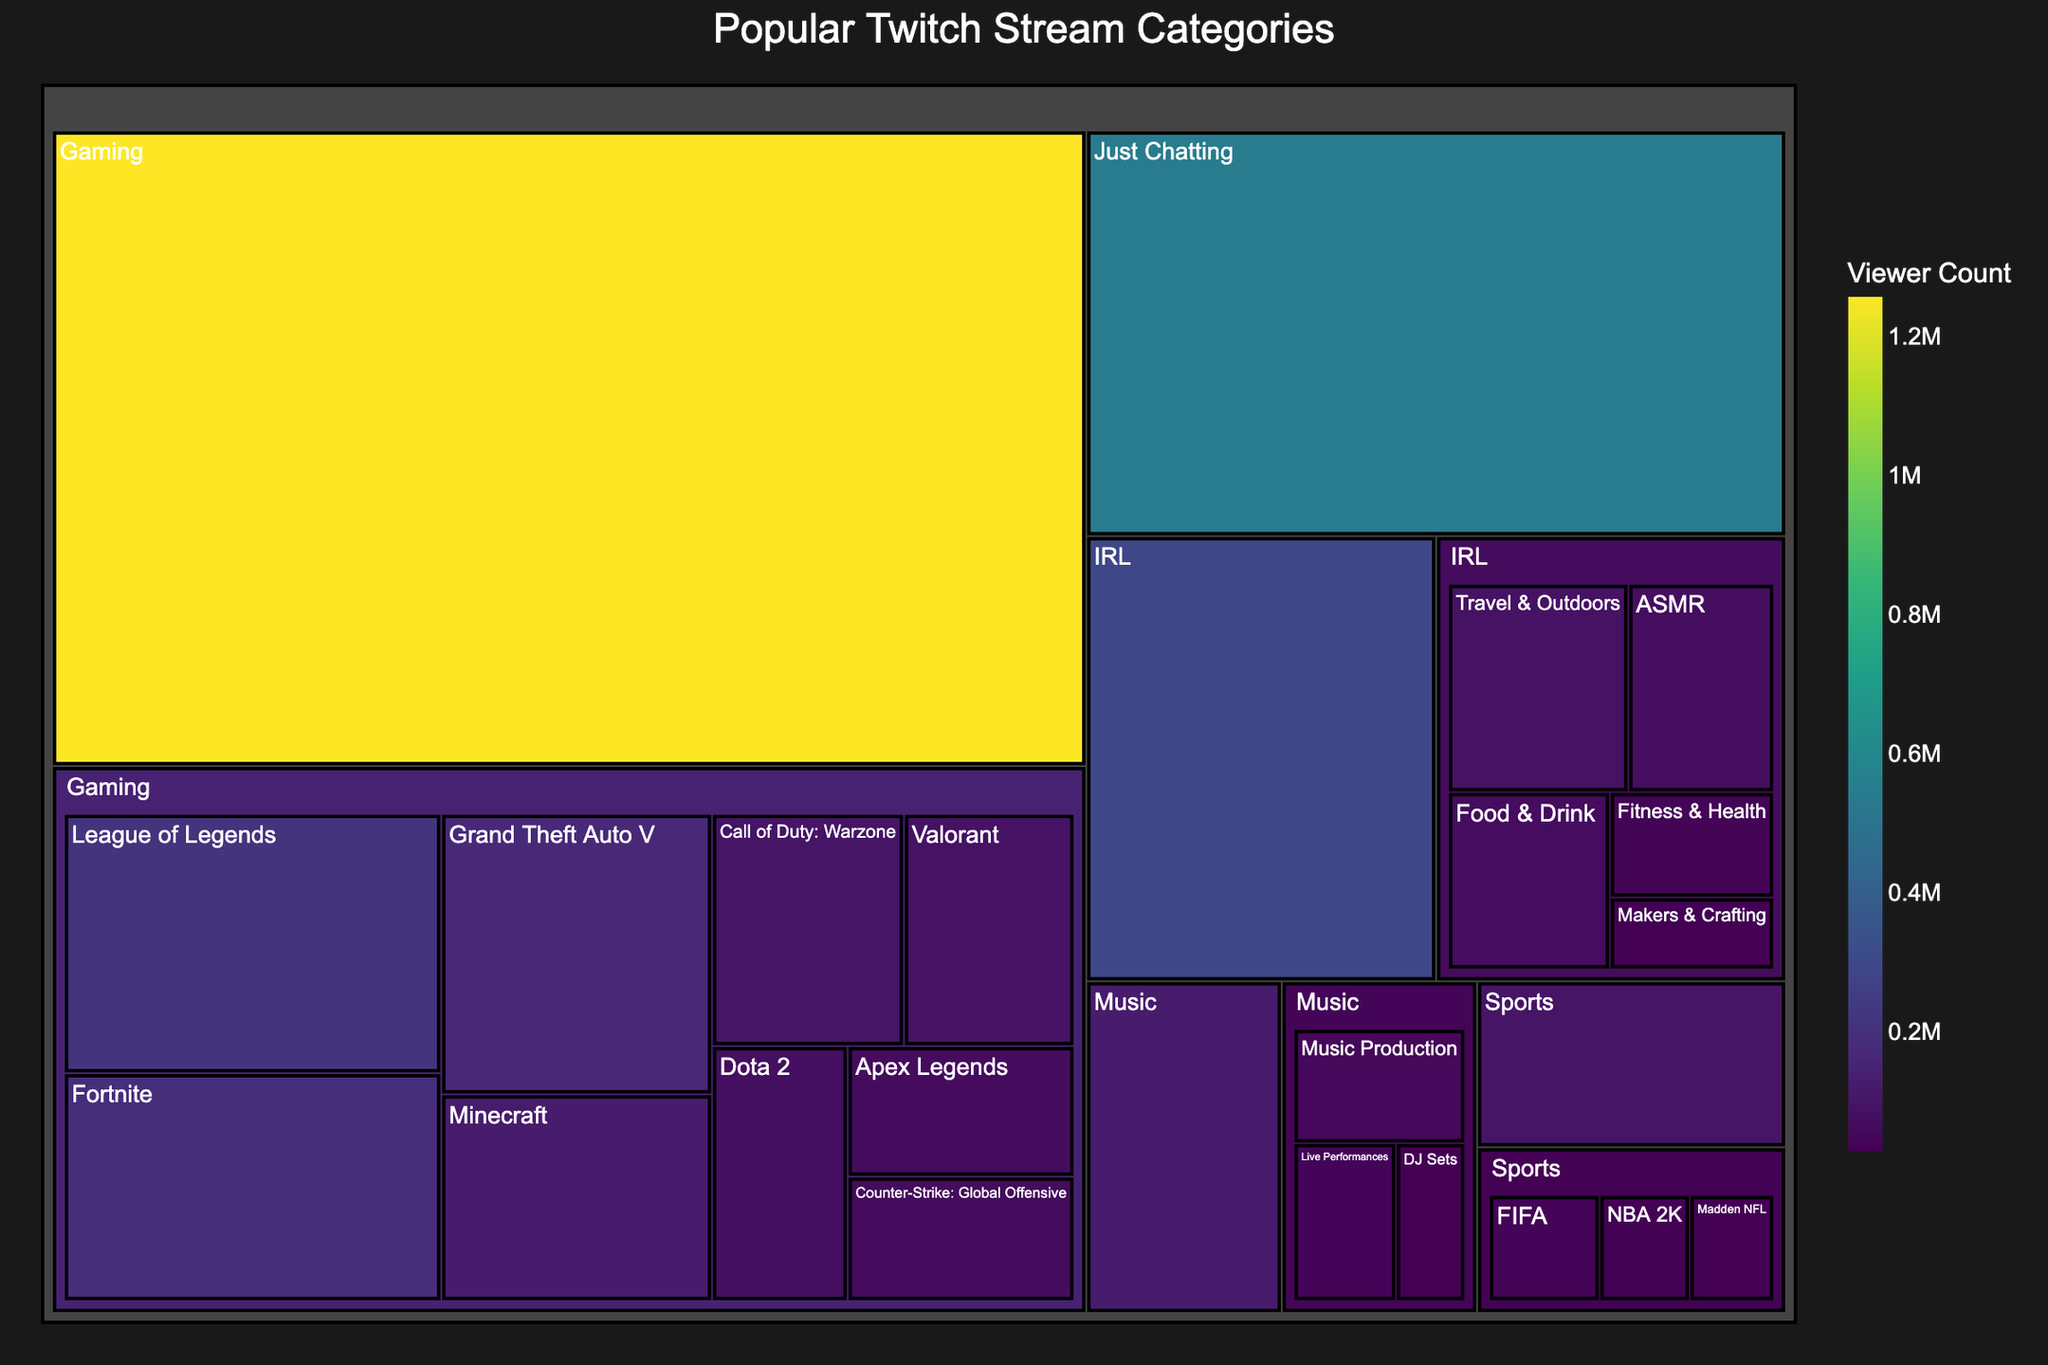What is the title of the treemap? The title is displayed at the top of the treemap, which summarizes the main topic being visualized.
Answer: Popular Twitch Stream Categories Which category has the highest viewer count? By looking at the largest segment in the treemap, you can identify the category with the highest value.
Answer: Gaming How many categories are shown in the treemap? By counting the unique top-level categories, you can determine the number presented.
Answer: 5 What is the viewer count for "Just Chatting"? Observe the specific segment labeled "Just Chatting" and read its associated viewer count.
Answer: 543,000 Compare the viewer counts of "IRL" and "Music". Which one is higher and by how much? Subtract the viewer count of "Music" from "IRL".
Answer: IRL is higher by 174,000 Within the Music category, which subcategory has the fewest viewers? By identifying the smallest segment within the Music category, you can find the subcategory with the least viewers.
Answer: DJ Sets Which subcategory of Gaming has the highest viewer count? Find the largest subcategory segment within the Gaming category.
Answer: League of Legends What is the total viewer count for all Music subcategories combined? Add up the viewer counts of all subcategories under Music.
Answer: 124,000 If you combine the viewer counts of the top three Gaming subcategories, what is the total? Add the viewer counts of the top three segments under Gaming: League of Legends, Fortnite, and Grand Theft Auto V.
Answer: 571,000 Which has more viewers: "Travel & Outdoors" in the IRL category or "DJ Sets" in the Music category? Compare the viewer counts of "Travel & Outdoors" and "DJ Sets".
Answer: Travel & Outdoors 